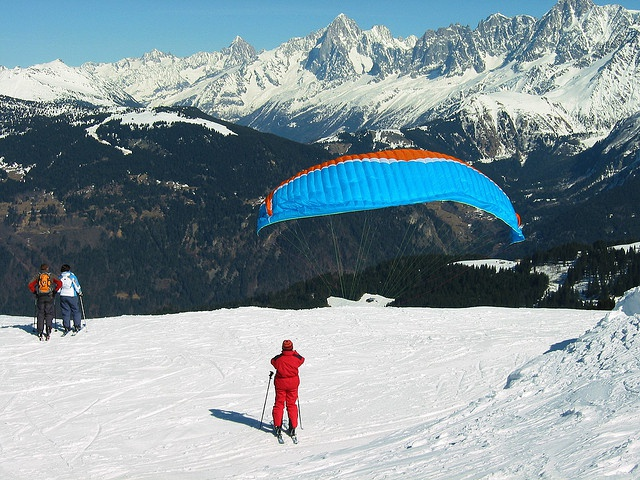Describe the objects in this image and their specific colors. I can see people in lightblue, brown, black, and maroon tones, people in lightblue, black, gray, and maroon tones, people in lightblue, black, white, gray, and darkblue tones, skis in lightblue, gray, lightgray, black, and darkgray tones, and backpack in lightblue, black, red, orange, and gray tones in this image. 